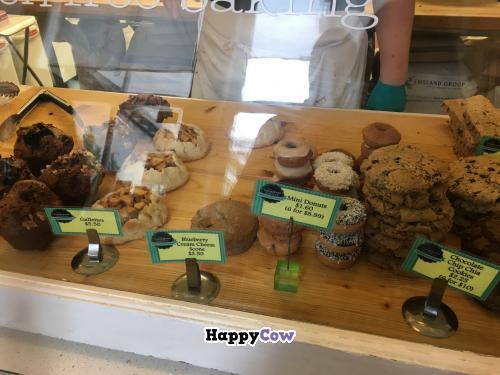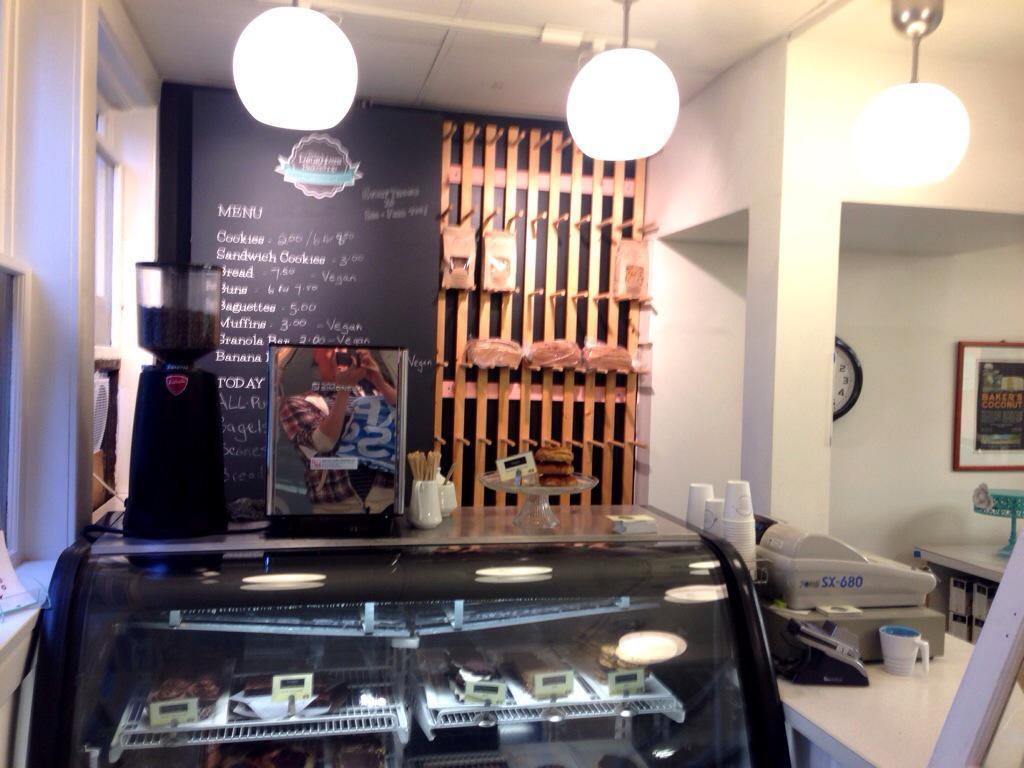The first image is the image on the left, the second image is the image on the right. Assess this claim about the two images: "The image on the left shows desserts in the foreground and exactly three people.". Correct or not? Answer yes or no. No. The first image is the image on the left, the second image is the image on the right. Assess this claim about the two images: "One image includes a girl at least on the right of an adult woman, and they are standing behind a rectangle of glass.". Correct or not? Answer yes or no. No. 